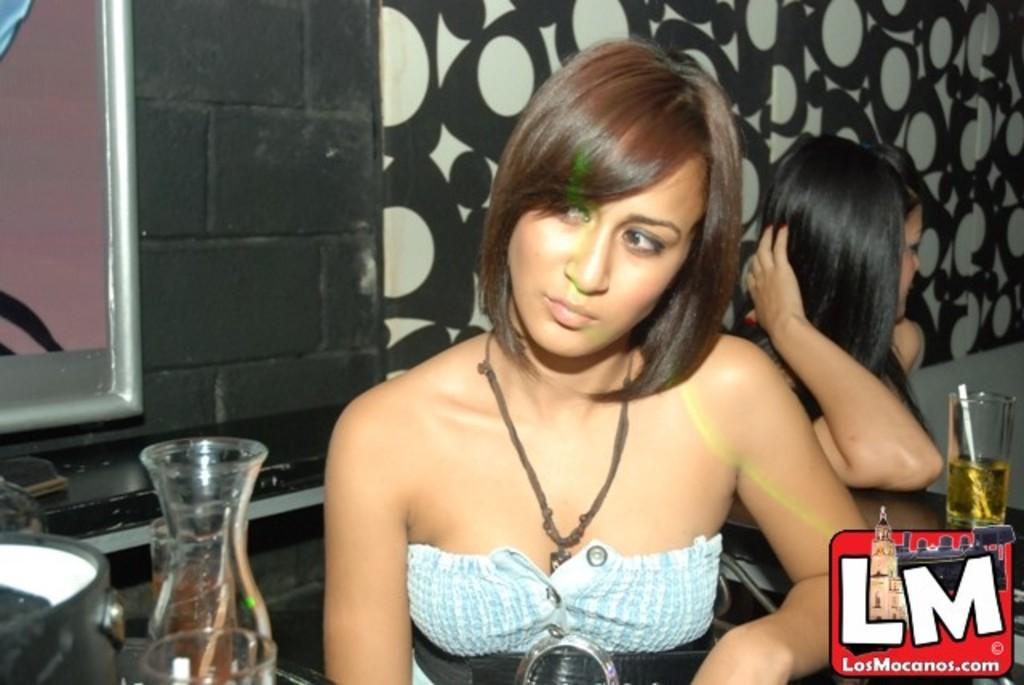Can you describe this image briefly? In this image there are people and we can see glasses, jug and a vessel placed on the tables. In the background there is a wall. On the left we can see a window. 